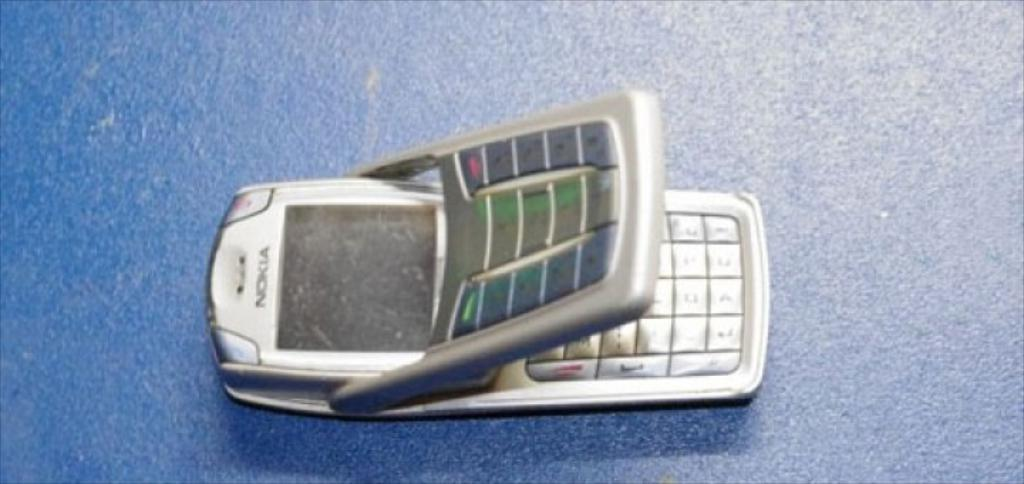Provide a one-sentence caption for the provided image. A Nokia flip phone that is wedged open. 